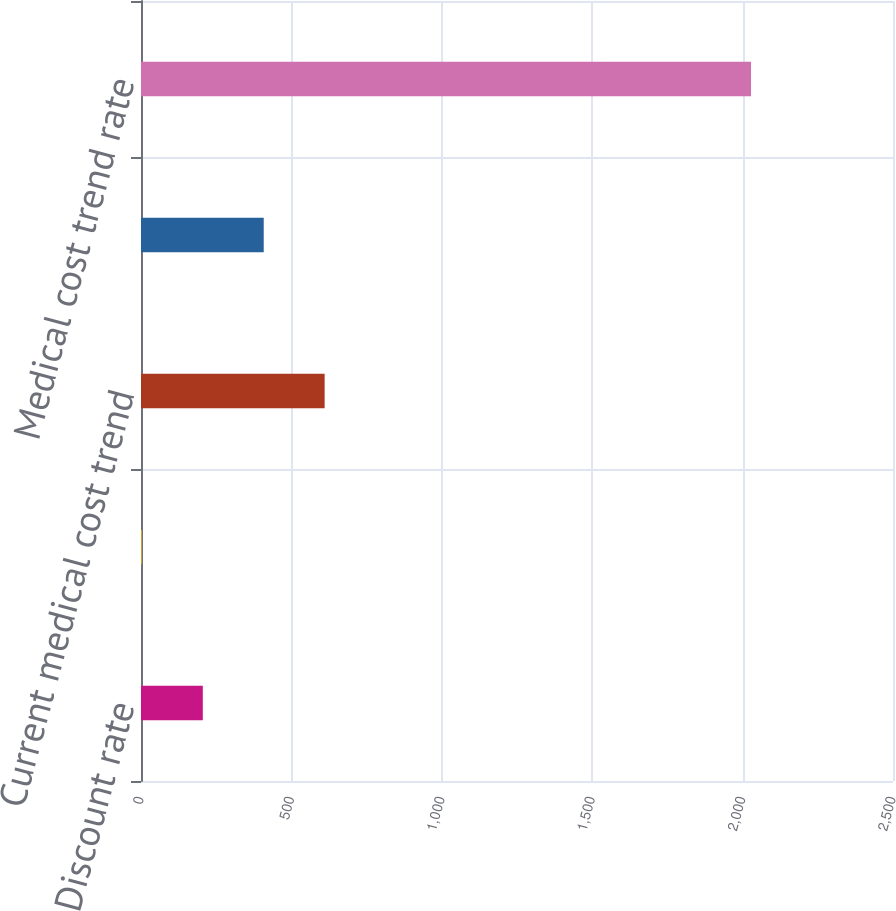Convert chart to OTSL. <chart><loc_0><loc_0><loc_500><loc_500><bar_chart><fcel>Discount rate<fcel>Average increase in<fcel>Current medical cost trend<fcel>Ultimate medical cost trend<fcel>Medical cost trend rate<nl><fcel>205.5<fcel>3<fcel>610.5<fcel>408<fcel>2028<nl></chart> 